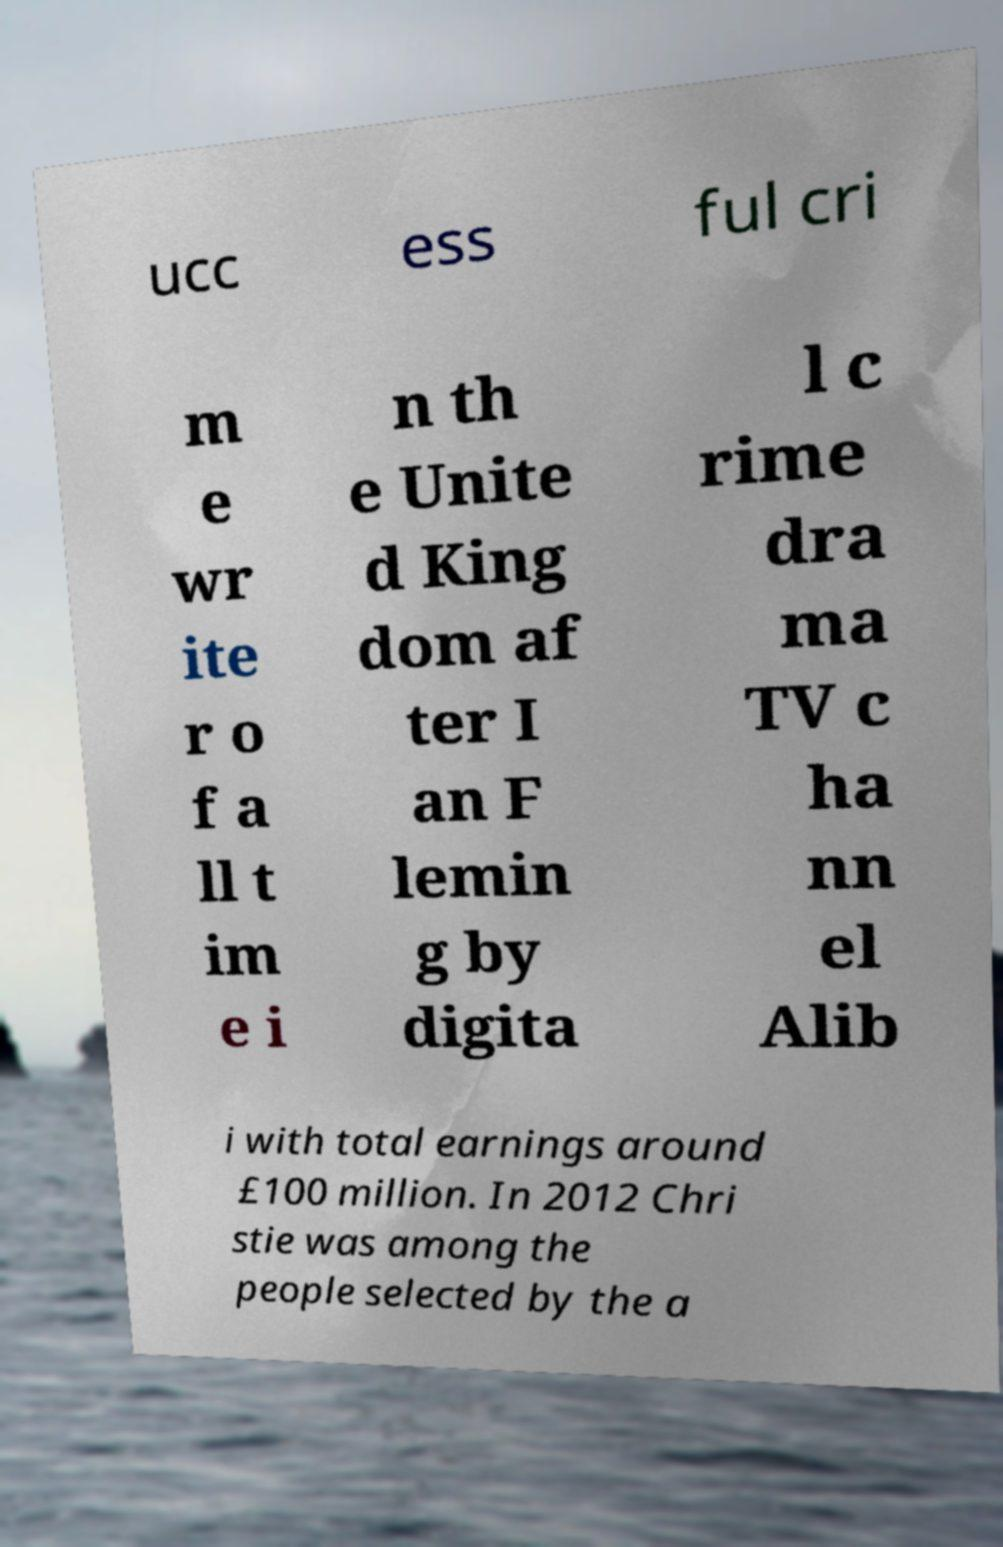For documentation purposes, I need the text within this image transcribed. Could you provide that? ucc ess ful cri m e wr ite r o f a ll t im e i n th e Unite d King dom af ter I an F lemin g by digita l c rime dra ma TV c ha nn el Alib i with total earnings around £100 million. In 2012 Chri stie was among the people selected by the a 